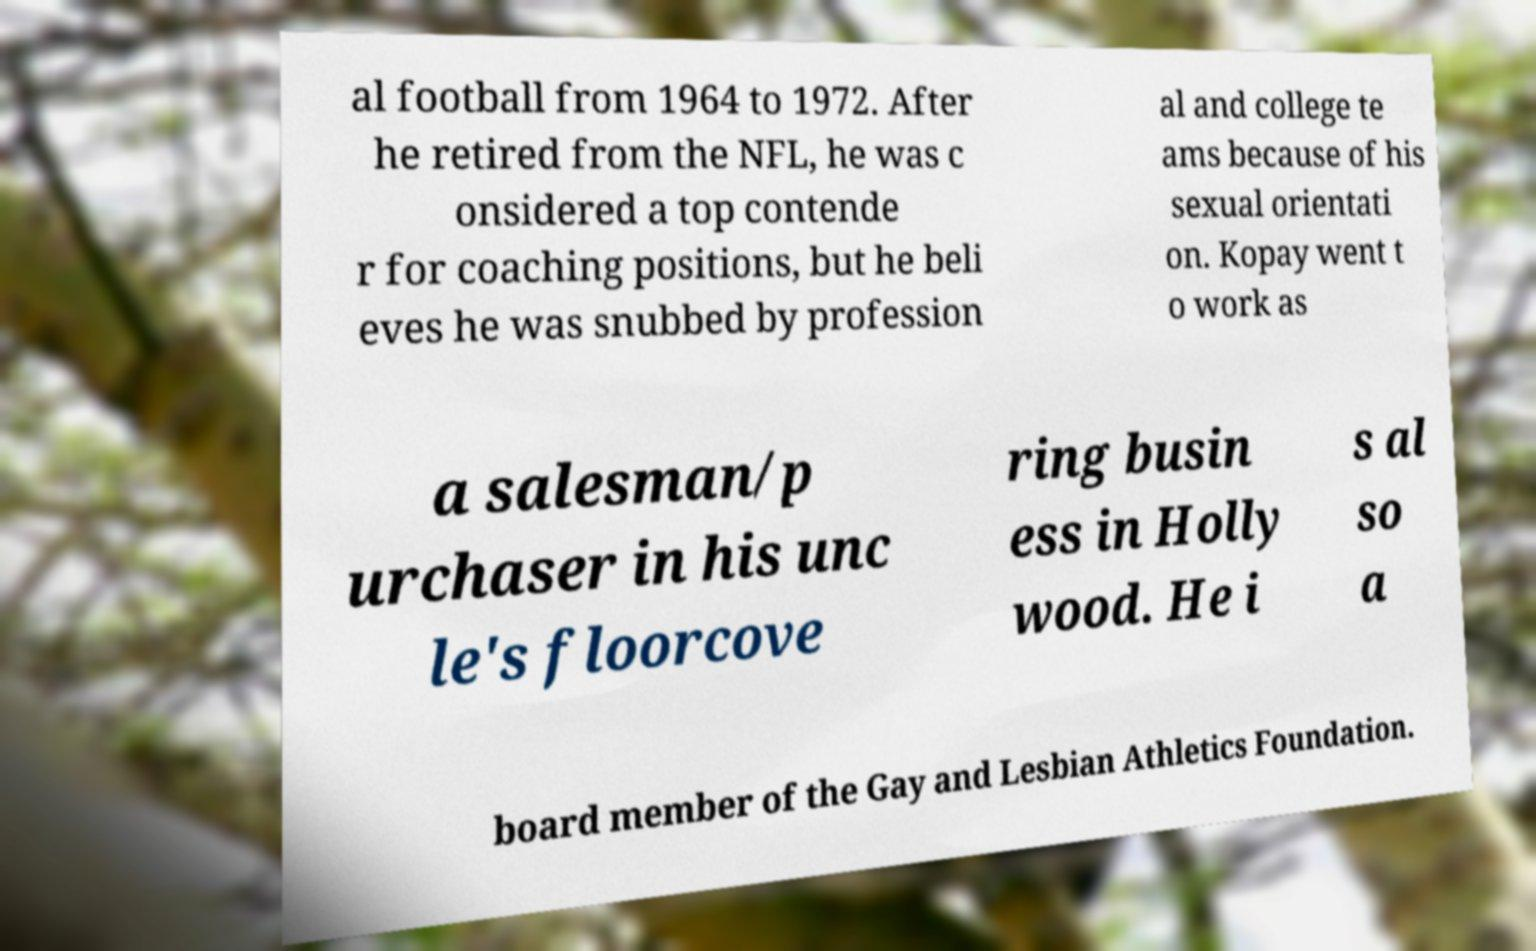There's text embedded in this image that I need extracted. Can you transcribe it verbatim? al football from 1964 to 1972. After he retired from the NFL, he was c onsidered a top contende r for coaching positions, but he beli eves he was snubbed by profession al and college te ams because of his sexual orientati on. Kopay went t o work as a salesman/p urchaser in his unc le's floorcove ring busin ess in Holly wood. He i s al so a board member of the Gay and Lesbian Athletics Foundation. 